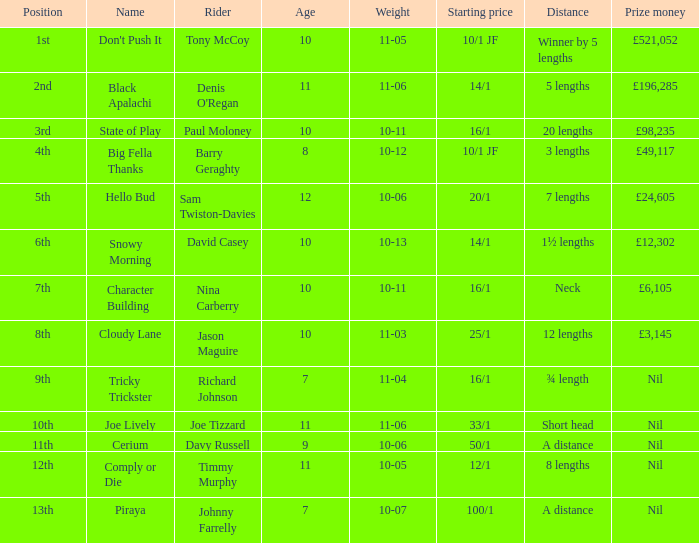How significant was nina carberry's winnings? £6,105. 